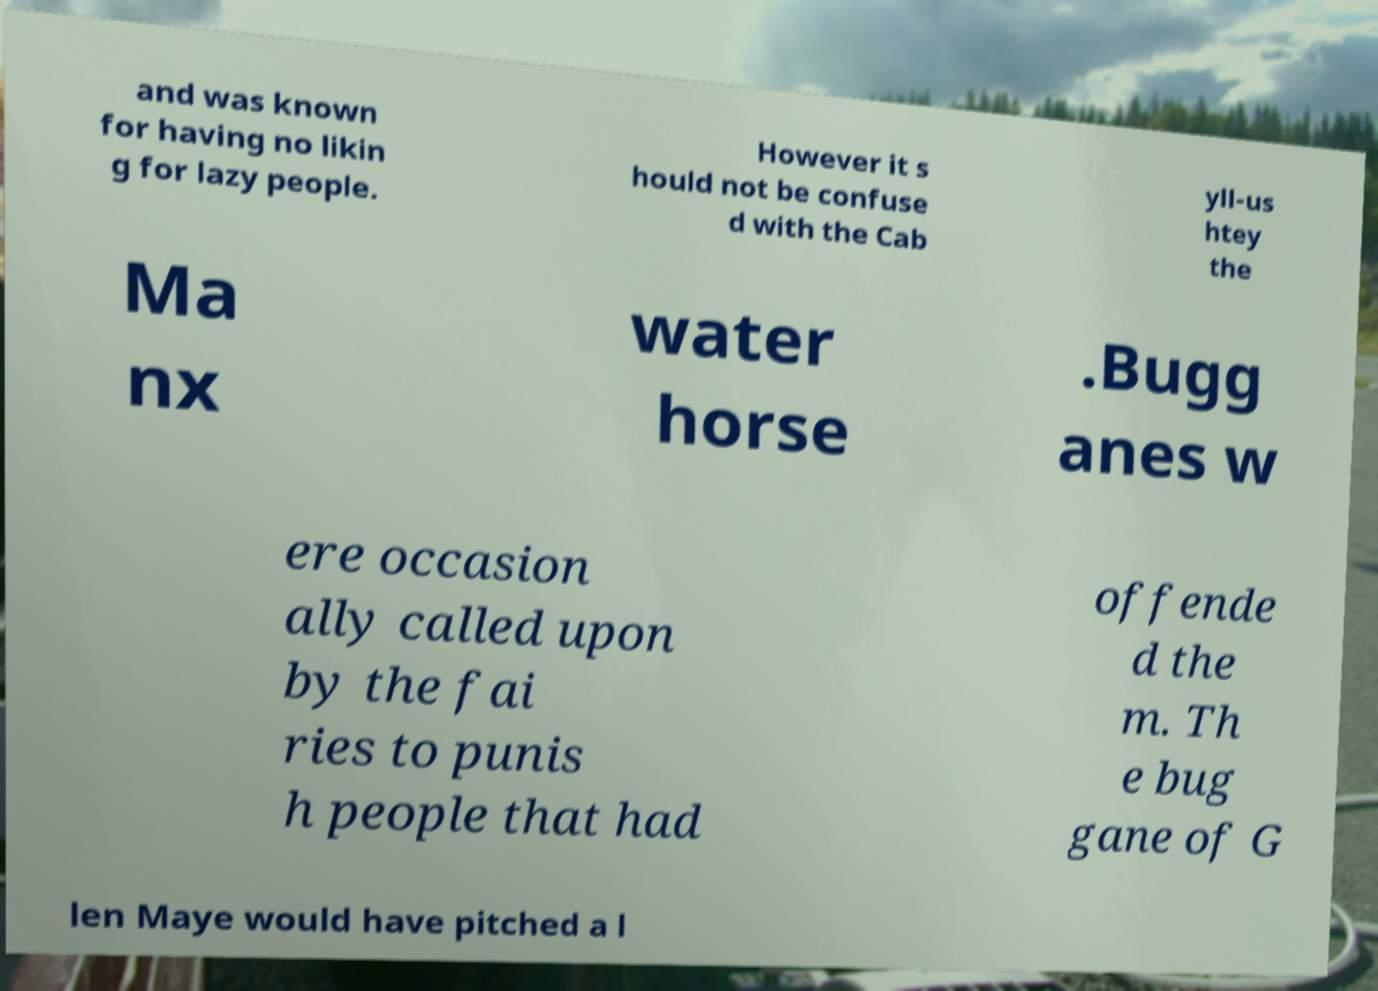Please identify and transcribe the text found in this image. and was known for having no likin g for lazy people. However it s hould not be confuse d with the Cab yll-us htey the Ma nx water horse .Bugg anes w ere occasion ally called upon by the fai ries to punis h people that had offende d the m. Th e bug gane of G len Maye would have pitched a l 